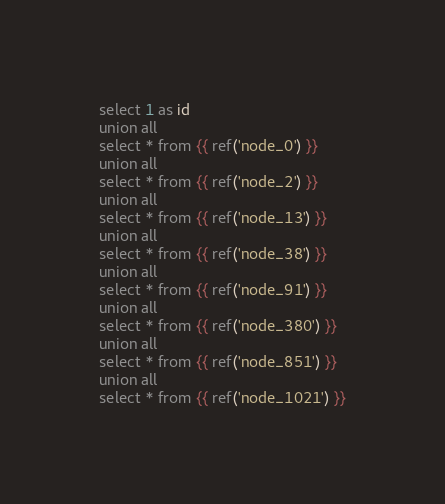<code> <loc_0><loc_0><loc_500><loc_500><_SQL_>select 1 as id
union all
select * from {{ ref('node_0') }}
union all
select * from {{ ref('node_2') }}
union all
select * from {{ ref('node_13') }}
union all
select * from {{ ref('node_38') }}
union all
select * from {{ ref('node_91') }}
union all
select * from {{ ref('node_380') }}
union all
select * from {{ ref('node_851') }}
union all
select * from {{ ref('node_1021') }}
</code> 